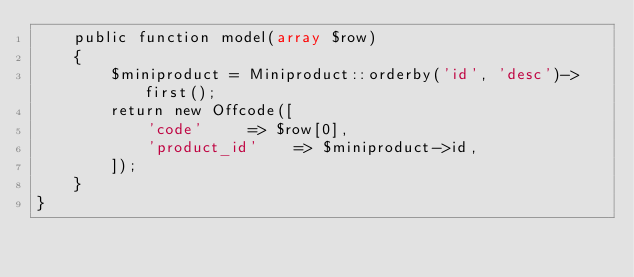Convert code to text. <code><loc_0><loc_0><loc_500><loc_500><_PHP_>    public function model(array $row)
    {
        $miniproduct = Miniproduct::orderby('id', 'desc')->first();
        return new Offcode([
            'code'     => $row[0],
            'product_id'    => $miniproduct->id,
        ]);
    }
}</code> 